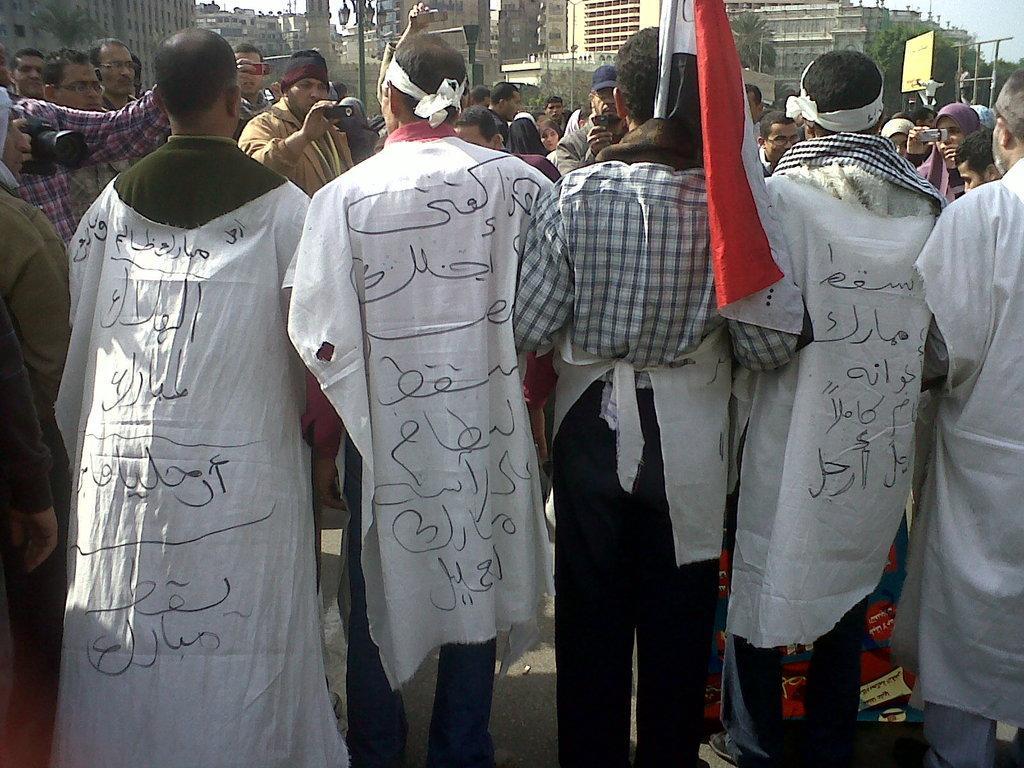Please provide a concise description of this image. In this image there are many people standing on the road. In the foreground there are five people. In the center there is a person holding a flag. In front of them there are people holding cameras in their hands. In the background there are buildings, street light poles and trees. 